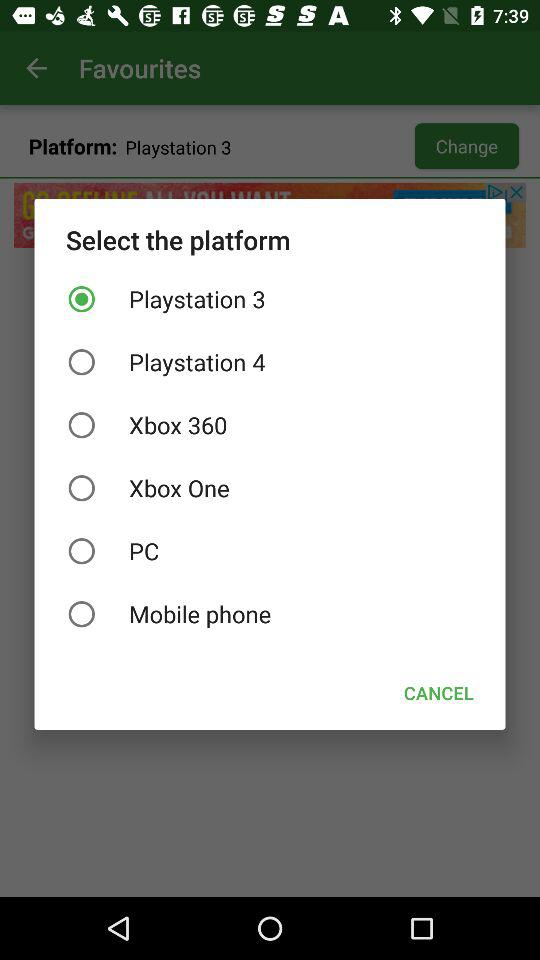How many platforms are available to choose from?
Answer the question using a single word or phrase. 6 